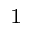<formula> <loc_0><loc_0><loc_500><loc_500>_ { 1 }</formula> 